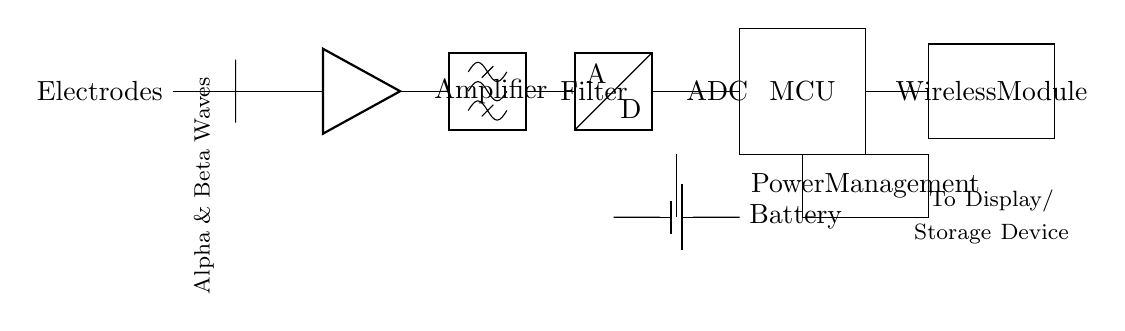What primary function does the amplifier serve in this circuit? The amplifier boosts the weak signals from the electrodes to a usable level for further processing. This is essential because the EEG signals recorded from the scalp are typically very low in amplitude and need amplification for accurate measurement.
Answer: Boosting signals What type of filter is used in the circuit? The circuit employs a bandpass filter to isolate the specific frequency range associated with alpha and beta brain waves. A bandpass filter allows signals within a certain range to pass and attenuates those outside that range.
Answer: Bandpass What is the role of the microcontroller in this system? The microcontroller processes the digitized signals received from the ADC and manages data transmission to the wireless module. It controls the overall operation of the device, enabling functionalities like signal processing and communication.
Answer: Processing data How many main components are there in this circuit? There are six main components including electrodes, amplifier, filter, ADC, microcontroller, and wireless module. Each component plays a unique role in achieving the device's functionality.
Answer: Six Which part of the circuit connects to a display or storage device? The connection to the display or storage device is made at the output of the wireless module, where processed data is transmitted for visualization or analysis. This component interfaces with external devices for further use of the data collected.
Answer: Wireless module What provides power to the entire circuit? The entire circuit is powered by a battery, which supplies the necessary voltage and current to all components. This component is crucial for the portability of the device, allowing it to function without being tethered to a wall outlet.
Answer: Battery 